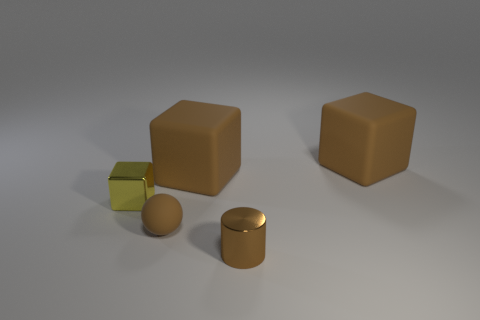There is a tiny object that is in front of the small brown rubber ball; is its color the same as the rubber object that is in front of the small metallic block?
Keep it short and to the point. Yes. There is a yellow object behind the small shiny cylinder right of the yellow metal object; what is it made of?
Offer a terse response. Metal. How many metal objects are small brown balls or big brown objects?
Offer a terse response. 0. What number of large matte blocks are the same color as the small rubber object?
Your answer should be compact. 2. There is a big matte object that is to the left of the tiny brown metallic object; are there any blocks that are to the left of it?
Give a very brief answer. Yes. What number of shiny objects are in front of the yellow metal object and behind the small brown metallic cylinder?
Your answer should be compact. 0. What number of tiny yellow objects have the same material as the yellow cube?
Your response must be concise. 0. What is the size of the matte object that is in front of the yellow metallic object that is behind the tiny brown matte ball?
Offer a very short reply. Small. Is there a big matte object of the same shape as the small yellow shiny object?
Make the answer very short. Yes. Do the metal thing to the right of the yellow metallic block and the metallic object that is to the left of the small cylinder have the same size?
Keep it short and to the point. Yes. 